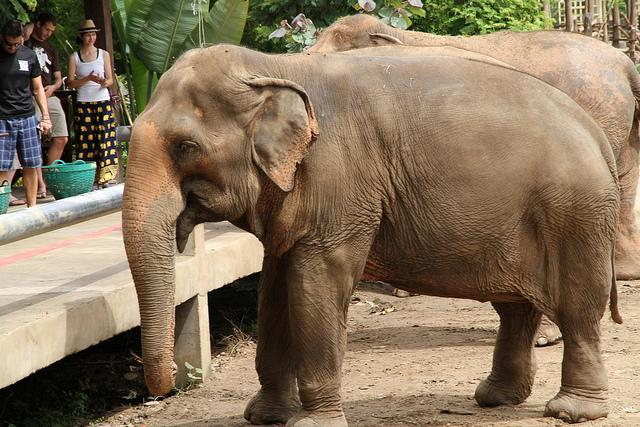What is this place? zoo 